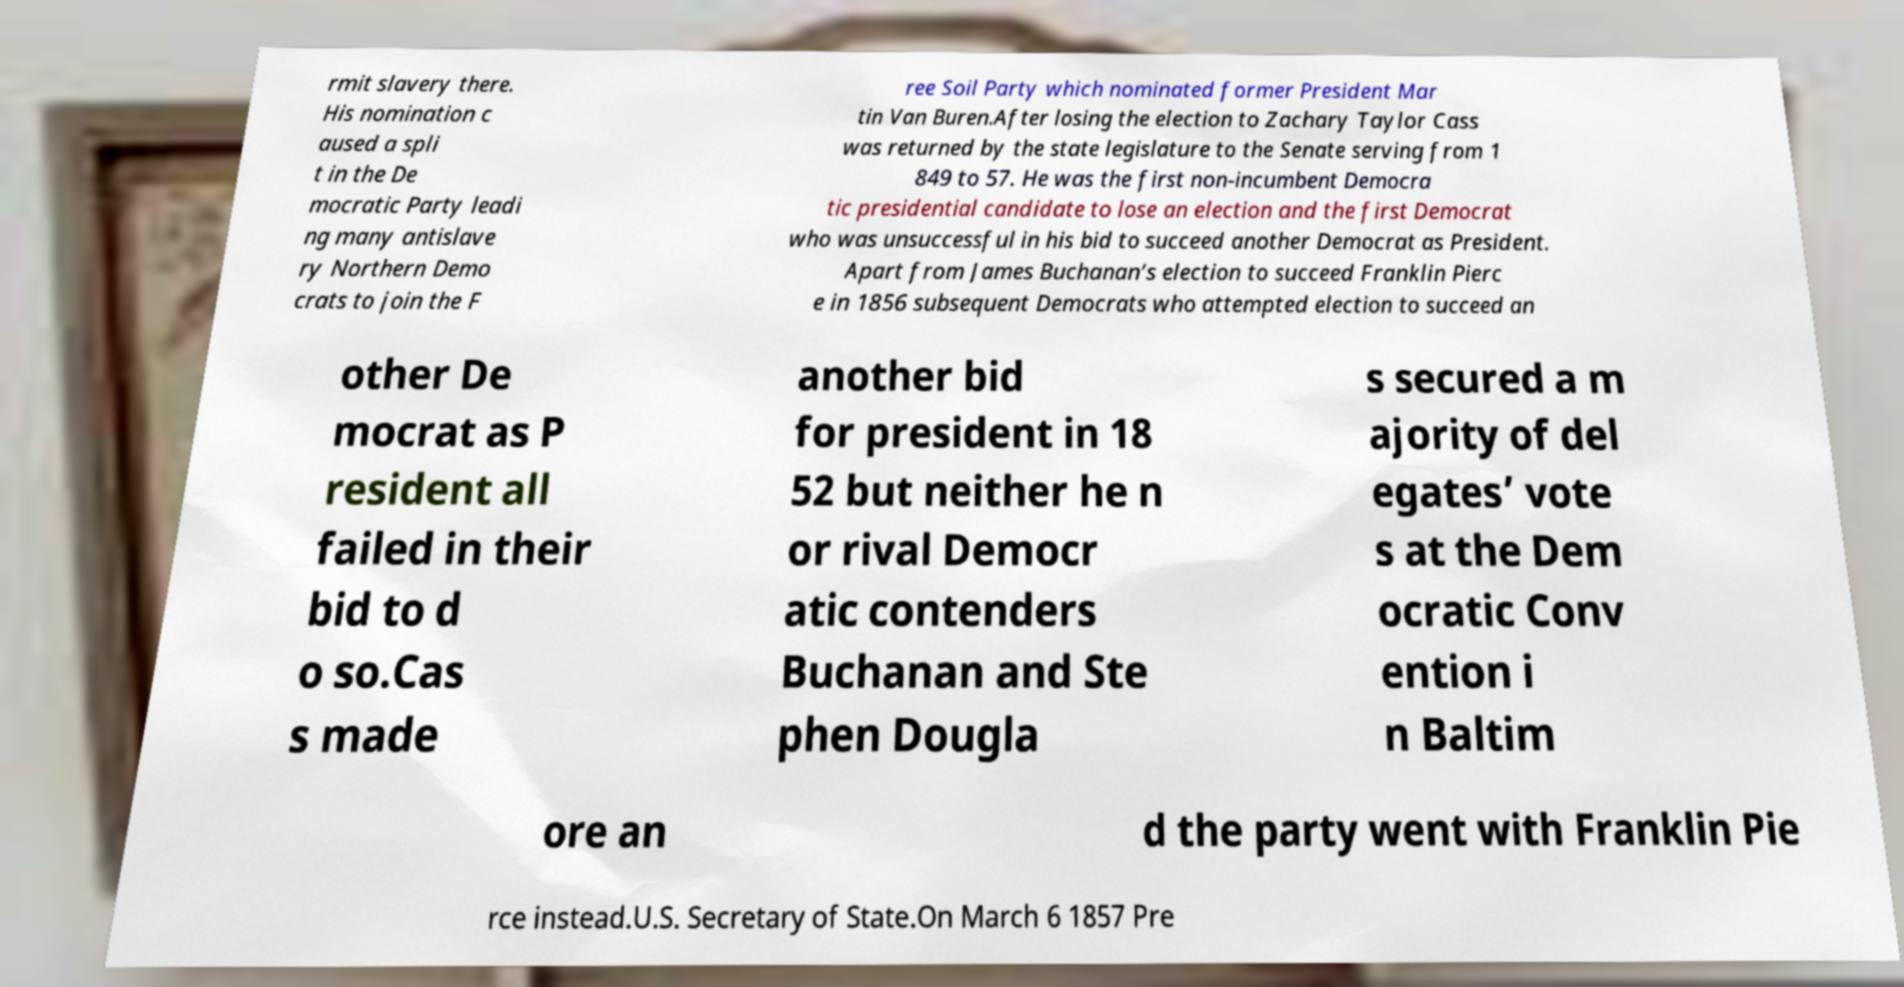Could you assist in decoding the text presented in this image and type it out clearly? rmit slavery there. His nomination c aused a spli t in the De mocratic Party leadi ng many antislave ry Northern Demo crats to join the F ree Soil Party which nominated former President Mar tin Van Buren.After losing the election to Zachary Taylor Cass was returned by the state legislature to the Senate serving from 1 849 to 57. He was the first non-incumbent Democra tic presidential candidate to lose an election and the first Democrat who was unsuccessful in his bid to succeed another Democrat as President. Apart from James Buchanan’s election to succeed Franklin Pierc e in 1856 subsequent Democrats who attempted election to succeed an other De mocrat as P resident all failed in their bid to d o so.Cas s made another bid for president in 18 52 but neither he n or rival Democr atic contenders Buchanan and Ste phen Dougla s secured a m ajority of del egates’ vote s at the Dem ocratic Conv ention i n Baltim ore an d the party went with Franklin Pie rce instead.U.S. Secretary of State.On March 6 1857 Pre 